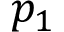Convert formula to latex. <formula><loc_0><loc_0><loc_500><loc_500>p _ { 1 }</formula> 